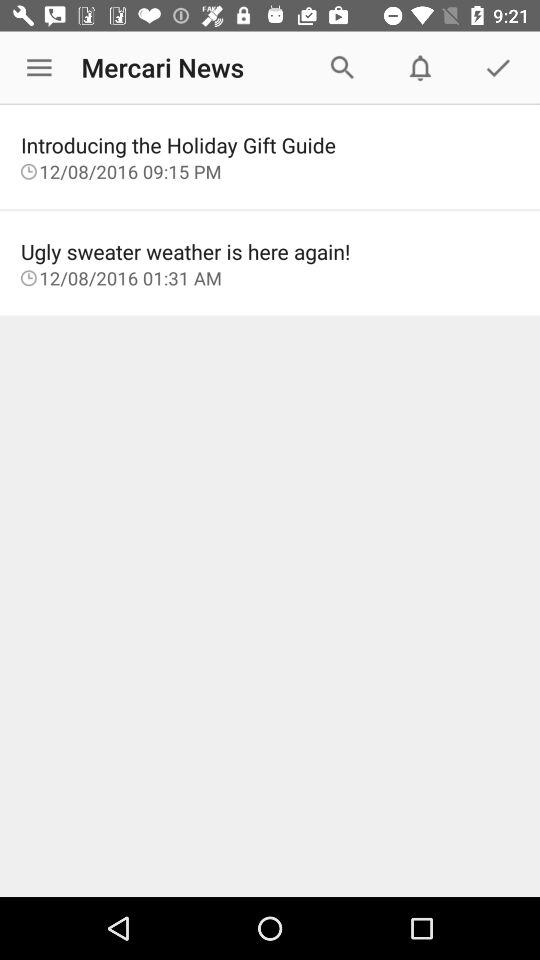Which news is updated at 09:15 PM? The news was updated was "Introducing the Holiday Gift Guide". 